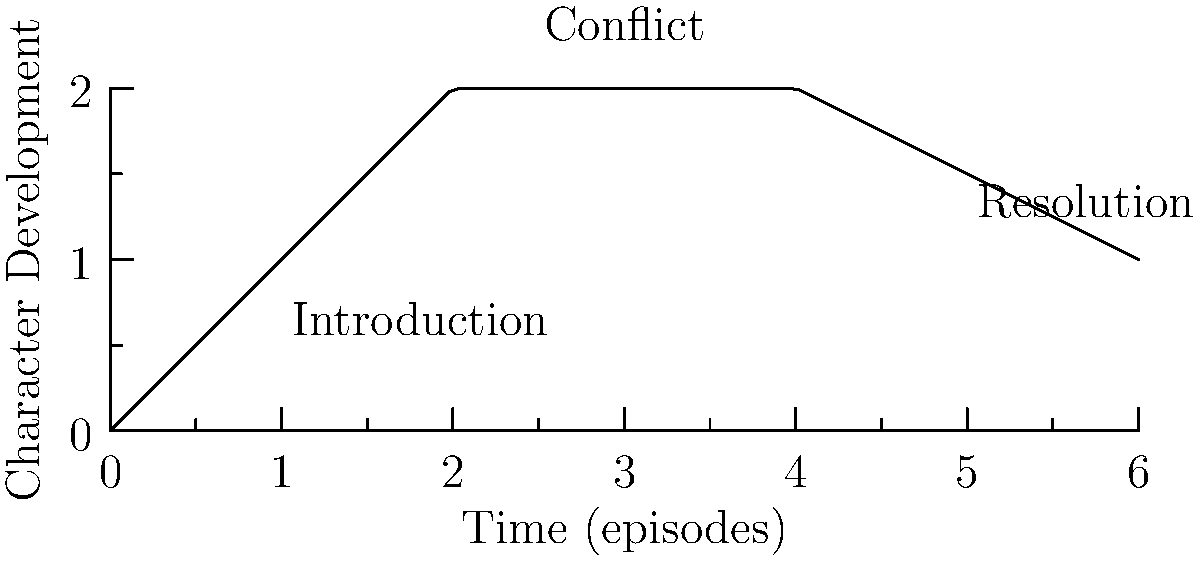As a television producer, you're developing a character arc for your new series. The piecewise function below represents different stages of the character's development over time:

$$f(x) = \begin{cases}
x & \text{if } 0 \leq x < 2 \\
2 & \text{if } 2 \leq x < 4 \\
-0.5x + 4 & \text{if } 4 \leq x \leq 6
\end{cases}$$

Where $x$ represents the number of episodes and $f(x)$ represents the level of character development. At which episode does the character's development begin to decline, and what is the rate of this decline? To answer this question, we need to analyze the piecewise function:

1. The function has three parts, representing different stages of character development:
   - $0 \leq x < 2$: Linear growth (Introduction)
   - $2 \leq x < 4$: Constant development (Conflict)
   - $4 \leq x \leq 6$: Linear decline (Resolution)

2. The character's development begins to decline at the start of the third piece of the function, which is when $x = 4$. This corresponds to the 4th episode.

3. To find the rate of decline, we need to look at the slope of the third piece of the function:
   $f(x) = -0.5x + 4$ for $4 \leq x \leq 6$

4. The slope of this linear function is -0.5, which represents the rate of decline.

5. In the context of television production, this means the character's development decreases by 0.5 units per episode starting from the 4th episode.
Answer: Episode 4; rate of -0.5 per episode 